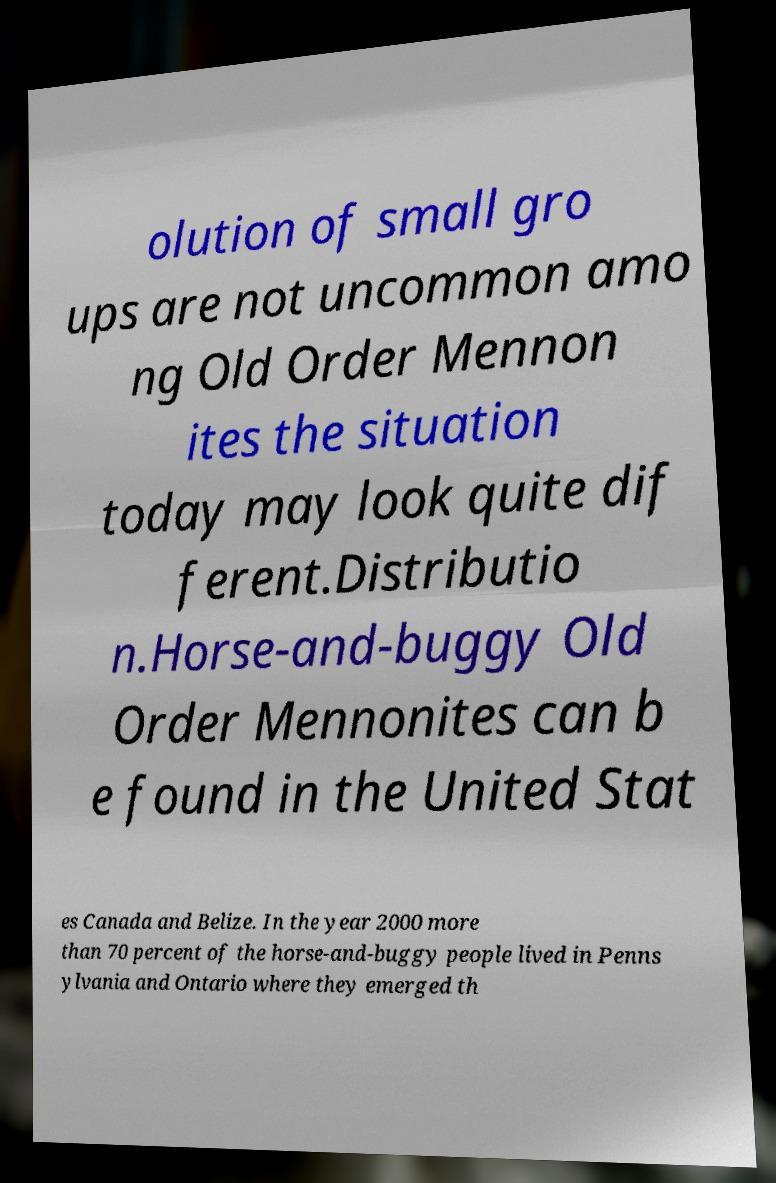I need the written content from this picture converted into text. Can you do that? olution of small gro ups are not uncommon amo ng Old Order Mennon ites the situation today may look quite dif ferent.Distributio n.Horse-and-buggy Old Order Mennonites can b e found in the United Stat es Canada and Belize. In the year 2000 more than 70 percent of the horse-and-buggy people lived in Penns ylvania and Ontario where they emerged th 